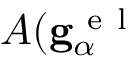Convert formula to latex. <formula><loc_0><loc_0><loc_500><loc_500>A ( g _ { \alpha } ^ { e l }</formula> 